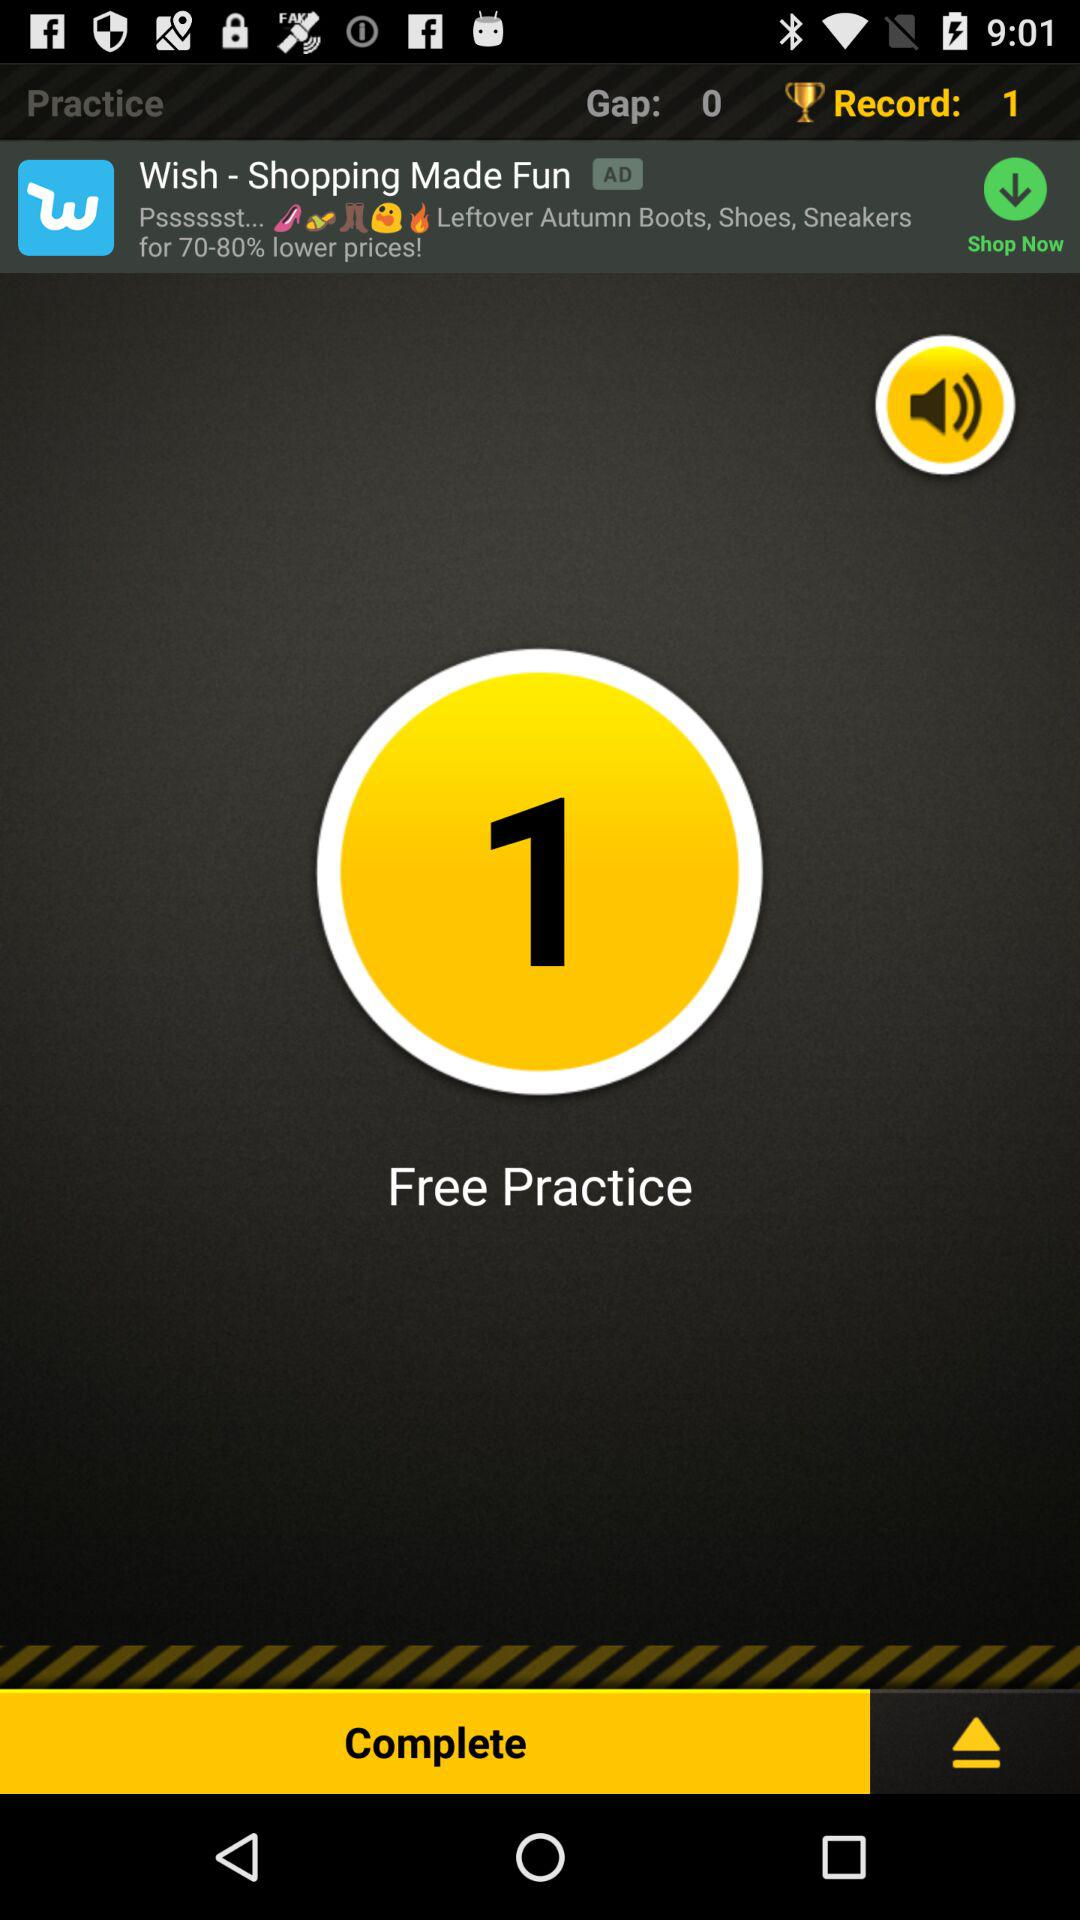How many records are there? There is 1 record. 